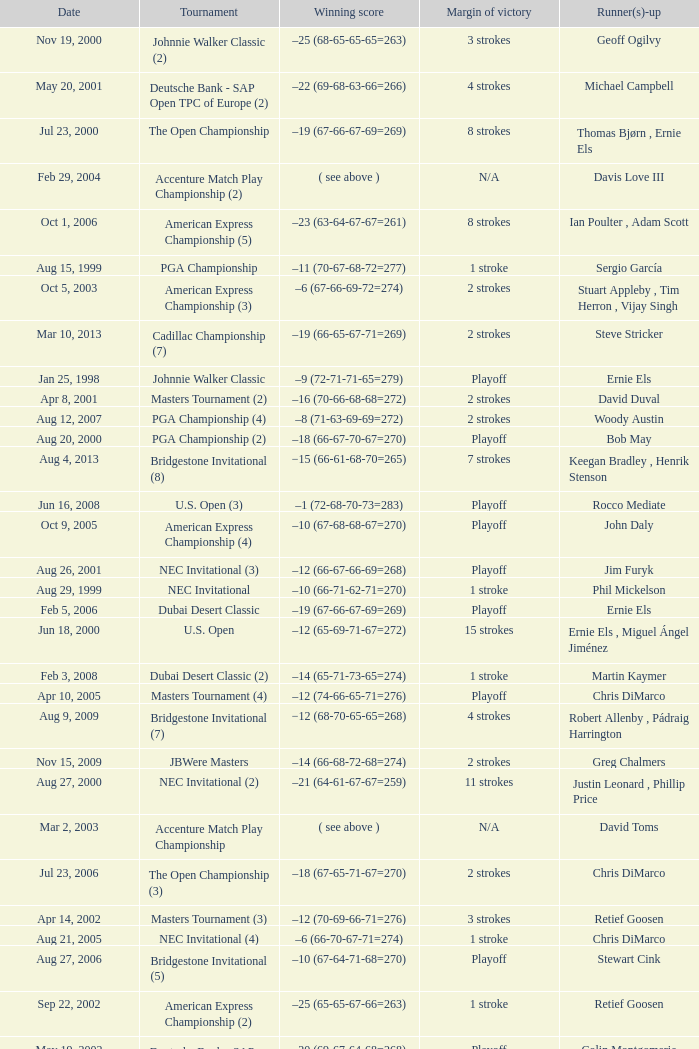Could you parse the entire table? {'header': ['Date', 'Tournament', 'Winning score', 'Margin of victory', 'Runner(s)-up'], 'rows': [['Nov 19, 2000', 'Johnnie Walker Classic (2)', '–25 (68-65-65-65=263)', '3 strokes', 'Geoff Ogilvy'], ['May 20, 2001', 'Deutsche Bank - SAP Open TPC of Europe (2)', '–22 (69-68-63-66=266)', '4 strokes', 'Michael Campbell'], ['Jul 23, 2000', 'The Open Championship', '–19 (67-66-67-69=269)', '8 strokes', 'Thomas Bjørn , Ernie Els'], ['Feb 29, 2004', 'Accenture Match Play Championship (2)', '( see above )', 'N/A', 'Davis Love III'], ['Oct 1, 2006', 'American Express Championship (5)', '–23 (63-64-67-67=261)', '8 strokes', 'Ian Poulter , Adam Scott'], ['Aug 15, 1999', 'PGA Championship', '–11 (70-67-68-72=277)', '1 stroke', 'Sergio García'], ['Oct 5, 2003', 'American Express Championship (3)', '–6 (67-66-69-72=274)', '2 strokes', 'Stuart Appleby , Tim Herron , Vijay Singh'], ['Mar 10, 2013', 'Cadillac Championship (7)', '–19 (66-65-67-71=269)', '2 strokes', 'Steve Stricker'], ['Jan 25, 1998', 'Johnnie Walker Classic', '–9 (72-71-71-65=279)', 'Playoff', 'Ernie Els'], ['Apr 8, 2001', 'Masters Tournament (2)', '–16 (70-66-68-68=272)', '2 strokes', 'David Duval'], ['Aug 12, 2007', 'PGA Championship (4)', '–8 (71-63-69-69=272)', '2 strokes', 'Woody Austin'], ['Aug 20, 2000', 'PGA Championship (2)', '–18 (66-67-70-67=270)', 'Playoff', 'Bob May'], ['Aug 4, 2013', 'Bridgestone Invitational (8)', '−15 (66-61-68-70=265)', '7 strokes', 'Keegan Bradley , Henrik Stenson'], ['Jun 16, 2008', 'U.S. Open (3)', '–1 (72-68-70-73=283)', 'Playoff', 'Rocco Mediate'], ['Oct 9, 2005', 'American Express Championship (4)', '–10 (67-68-68-67=270)', 'Playoff', 'John Daly'], ['Aug 26, 2001', 'NEC Invitational (3)', '–12 (66-67-66-69=268)', 'Playoff', 'Jim Furyk'], ['Aug 29, 1999', 'NEC Invitational', '–10 (66-71-62-71=270)', '1 stroke', 'Phil Mickelson'], ['Feb 5, 2006', 'Dubai Desert Classic', '–19 (67-66-67-69=269)', 'Playoff', 'Ernie Els'], ['Jun 18, 2000', 'U.S. Open', '–12 (65-69-71-67=272)', '15 strokes', 'Ernie Els , Miguel Ángel Jiménez'], ['Feb 3, 2008', 'Dubai Desert Classic (2)', '–14 (65-71-73-65=274)', '1 stroke', 'Martin Kaymer'], ['Apr 10, 2005', 'Masters Tournament (4)', '–12 (74-66-65-71=276)', 'Playoff', 'Chris DiMarco'], ['Aug 9, 2009', 'Bridgestone Invitational (7)', '−12 (68-70-65-65=268)', '4 strokes', 'Robert Allenby , Pádraig Harrington'], ['Nov 15, 2009', 'JBWere Masters', '–14 (66-68-72-68=274)', '2 strokes', 'Greg Chalmers'], ['Aug 27, 2000', 'NEC Invitational (2)', '–21 (64-61-67-67=259)', '11 strokes', 'Justin Leonard , Phillip Price'], ['Mar 2, 2003', 'Accenture Match Play Championship', '( see above )', 'N/A', 'David Toms'], ['Jul 23, 2006', 'The Open Championship (3)', '–18 (67-65-71-67=270)', '2 strokes', 'Chris DiMarco'], ['Apr 14, 2002', 'Masters Tournament (3)', '–12 (70-69-66-71=276)', '3 strokes', 'Retief Goosen'], ['Aug 21, 2005', 'NEC Invitational (4)', '–6 (66-70-67-71=274)', '1 stroke', 'Chris DiMarco'], ['Aug 27, 2006', 'Bridgestone Invitational (5)', '–10 (67-64-71-68=270)', 'Playoff', 'Stewart Cink'], ['Sep 22, 2002', 'American Express Championship (2)', '–25 (65-65-67-66=263)', '1 stroke', 'Retief Goosen'], ['May 19, 2002', 'Deutsche Bank - SAP Open TPC of Europe (3)', '–20 (69-67-64-68=268)', 'Playoff', 'Colin Montgomerie'], ['Jul 17, 2005', 'The Open Championship (2)', '–14 (66-67-71-70=274)', '5 strokes', 'Colin Montgomerie'], ['Mar 25, 2007', 'CA Championship (6)', '–10 (71-66-68-73=278)', '2 strokes', 'Brett Wetterich'], ['Jun 16, 2002', 'U.S. Open (2)', '–3 (67-68-70-72=277)', '3 strokes', 'Phil Mickelson'], ['Aug 5, 2007', 'Bridgestone Invitational (6)', '−8 (68-70-69-65=272)', '8 strokes', 'Justin Rose , Rory Sabbatini'], ['Aug 20, 2006', 'PGA Championship (3)', '–18 (69-68-65-68=270)', '5 strokes', 'Shaun Micheel'], ['Feb 24, 2008', 'Accenture Match Play Championship (3)', '( see above )', 'N/A', 'Stewart Cink'], ['May 24, 1999', 'Deutsche Bank - SAP Open TPC of Europe', '–15 (69-68-68-68=273)', '3 strokes', 'Retief Goosen'], ['Apr 13, 1997', 'Masters Tournament', '–18 (70-66-65-69=270)', '12 strokes', 'Tom Kite'], ['Nov 11, 1999', 'American Express Championship', '–6 (71-69-70-68=278)', 'Playoff', 'Miguel Ángel Jiménez']]} Who has the Winning score of –10 (66-71-62-71=270) ? Phil Mickelson. 